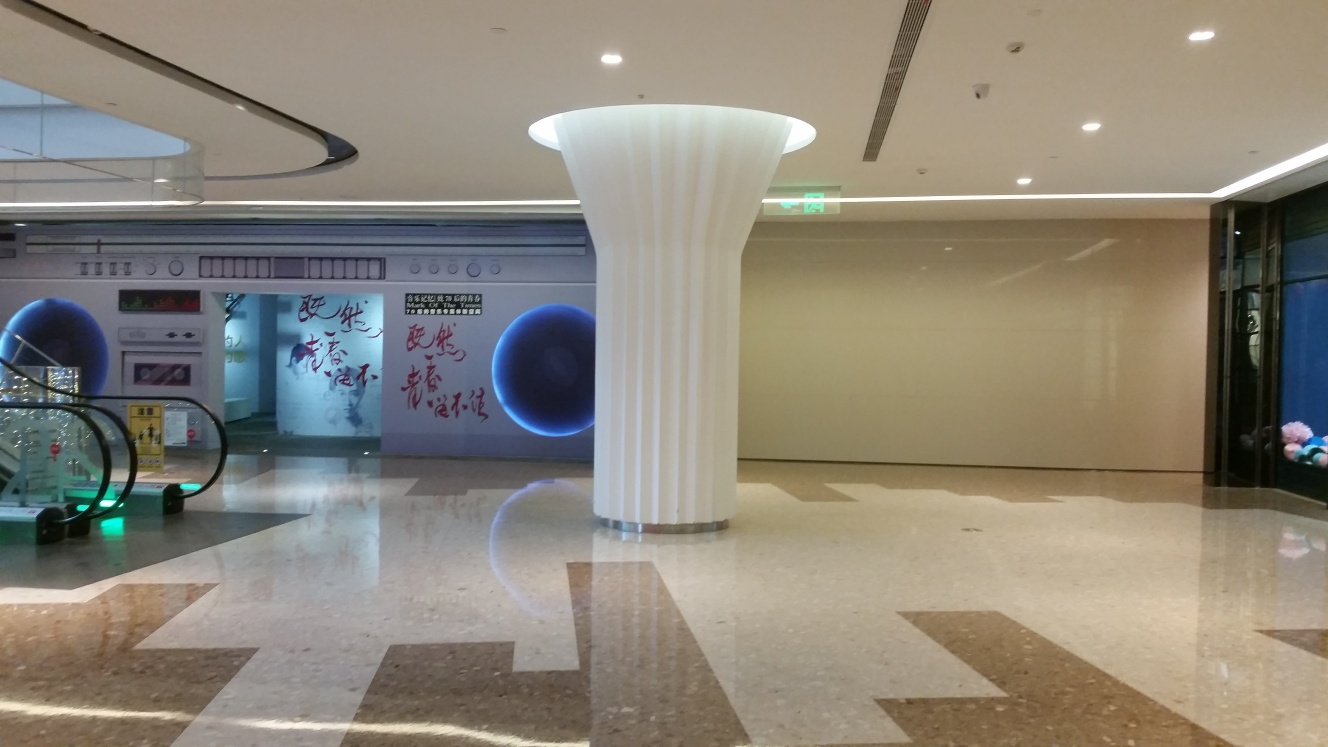Can you infer what type of building this is based on the picture? From the image, it seems to be an interior space of a public or commercial building, possibly a shopping mall or a cultural center, given the spacious layout, commercial signage, and artistic elements. Is there any indication of the location or cultural context? The writing on the walls appears to be in Chinese, which suggests that this building could be located in a Chinese-speaking region. The artwork and calligraphy also hint at cultural elements that are characteristic of East Asian aesthetics. 